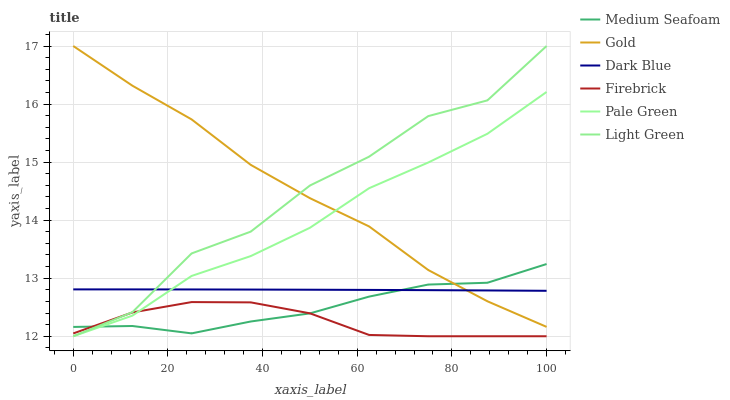Does Dark Blue have the minimum area under the curve?
Answer yes or no. No. Does Dark Blue have the maximum area under the curve?
Answer yes or no. No. Is Firebrick the smoothest?
Answer yes or no. No. Is Firebrick the roughest?
Answer yes or no. No. Does Dark Blue have the lowest value?
Answer yes or no. No. Does Dark Blue have the highest value?
Answer yes or no. No. Is Firebrick less than Gold?
Answer yes or no. Yes. Is Gold greater than Firebrick?
Answer yes or no. Yes. Does Firebrick intersect Gold?
Answer yes or no. No. 